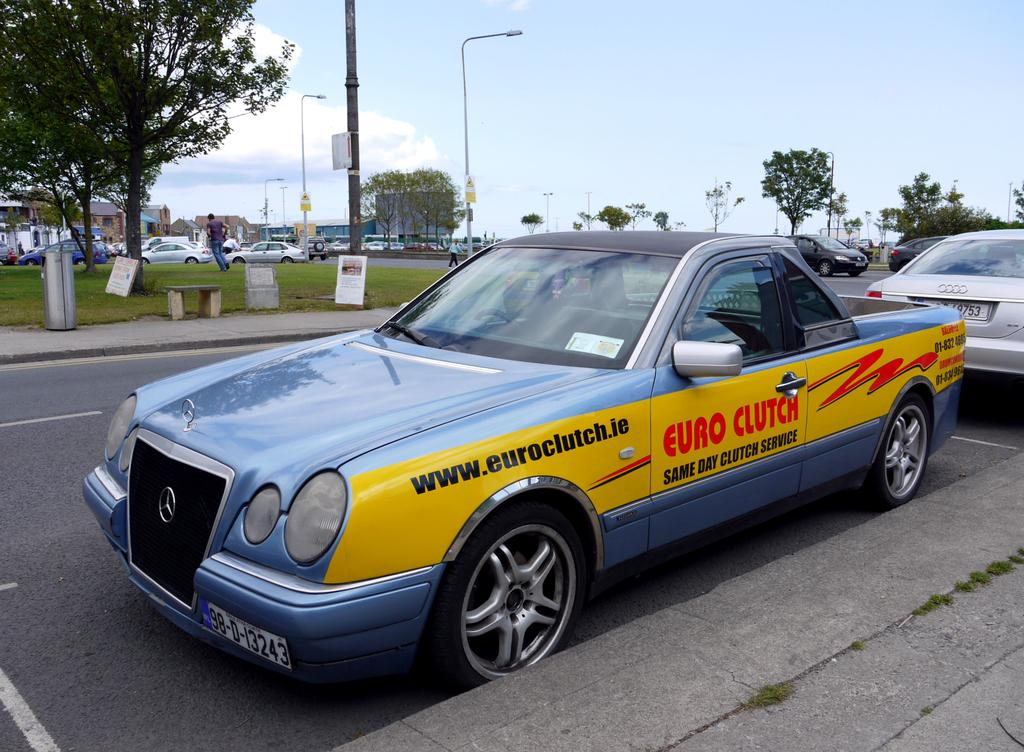<image>
Create a compact narrative representing the image presented. a car that has the word euro on it 